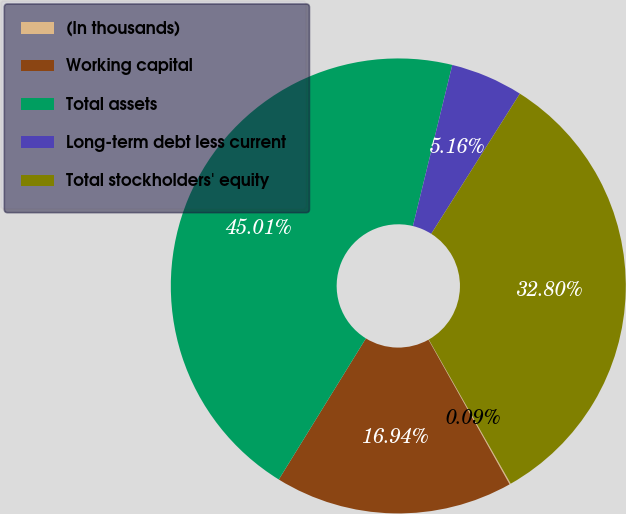<chart> <loc_0><loc_0><loc_500><loc_500><pie_chart><fcel>(In thousands)<fcel>Working capital<fcel>Total assets<fcel>Long-term debt less current<fcel>Total stockholders' equity<nl><fcel>0.09%<fcel>16.94%<fcel>45.01%<fcel>5.16%<fcel>32.8%<nl></chart> 